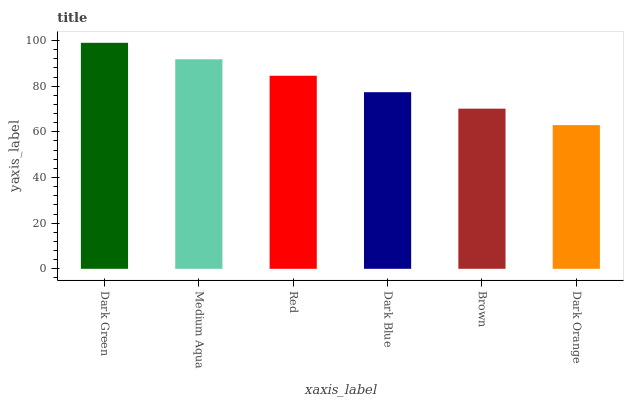Is Medium Aqua the minimum?
Answer yes or no. No. Is Medium Aqua the maximum?
Answer yes or no. No. Is Dark Green greater than Medium Aqua?
Answer yes or no. Yes. Is Medium Aqua less than Dark Green?
Answer yes or no. Yes. Is Medium Aqua greater than Dark Green?
Answer yes or no. No. Is Dark Green less than Medium Aqua?
Answer yes or no. No. Is Red the high median?
Answer yes or no. Yes. Is Dark Blue the low median?
Answer yes or no. Yes. Is Dark Blue the high median?
Answer yes or no. No. Is Dark Orange the low median?
Answer yes or no. No. 